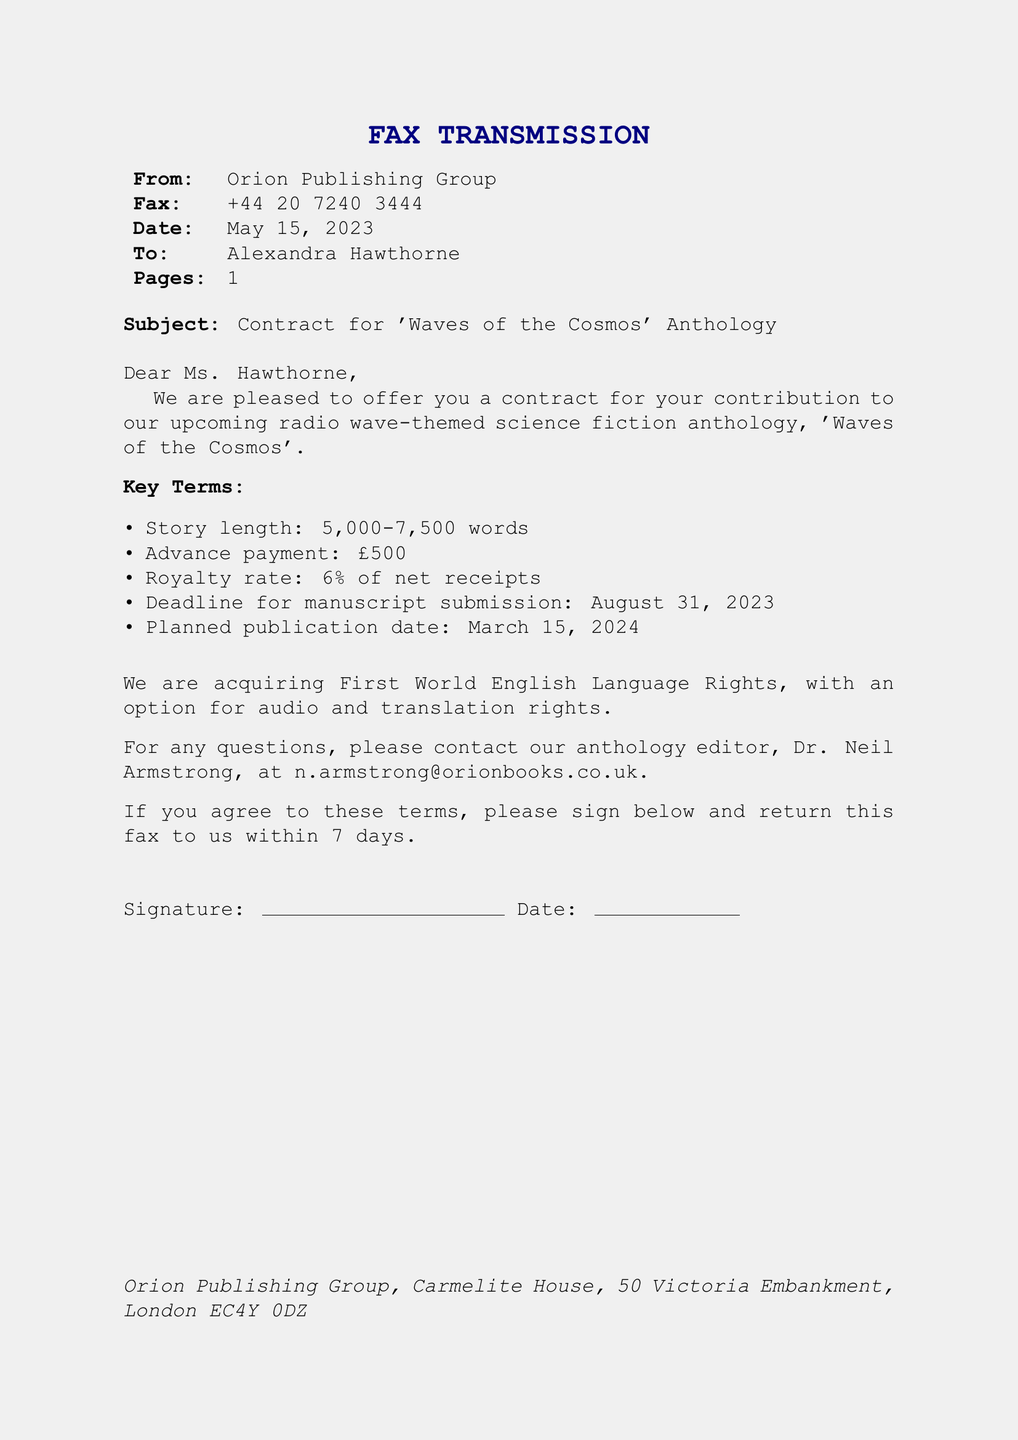What is the title of the anthology? The title of the anthology is specified in the subject line of the document.
Answer: 'Waves of the Cosmos' What is the advance payment? The advance payment is clearly stated in the key terms section of the document.
Answer: £500 What is the royalty rate? The document clearly states the royalty rate in the key terms section.
Answer: 6% of net receipts What is the deadline for manuscript submission? The deadline for submitting the manuscript is listed in the key terms section.
Answer: August 31, 2023 Who is the editor to contact? The editor's name is mentioned towards the end of the document for inquiries.
Answer: Dr. Neil Armstrong How many total pages does the fax contain? The document specifies the number of pages in the header.
Answer: 1 What rights is Orion Publishing Group acquiring? The rights being acquired are stated in the document.
Answer: First World English Language Rights What is the planned publication date? The planned publication date is provided in the key terms section.
Answer: March 15, 2024 How long should the story be? The required story length is mentioned in the key terms section of the document.
Answer: 5,000-7,500 words 